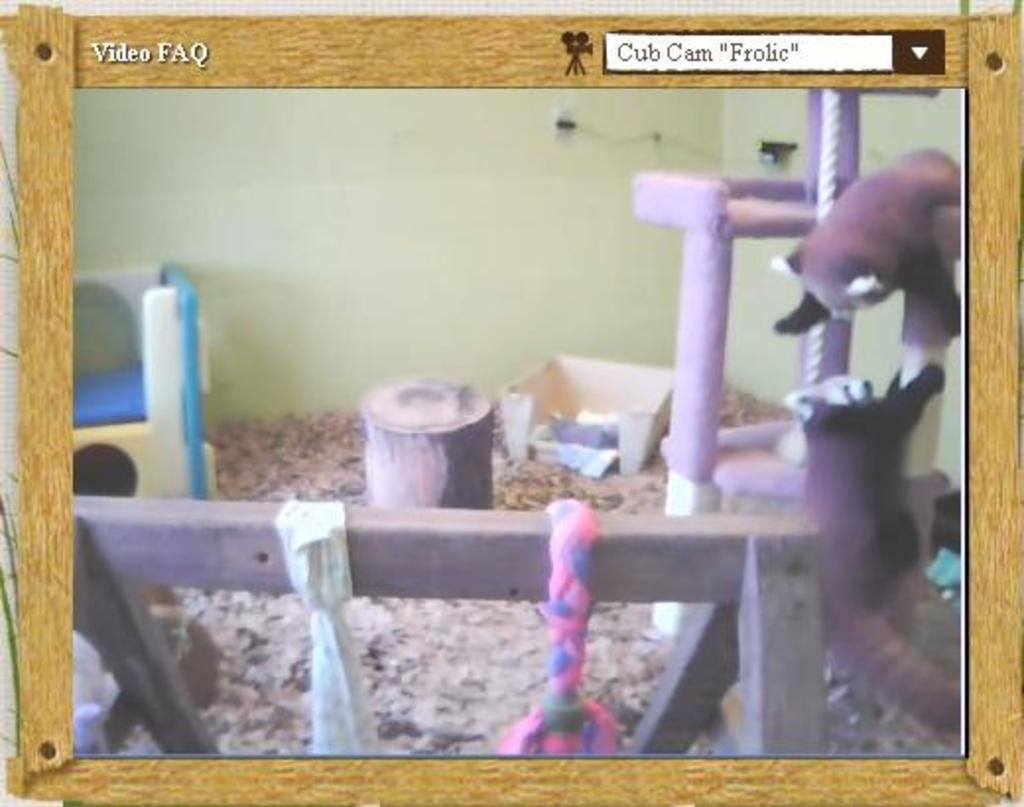What is the main subject in the center of the image? There is a poster in the center of the image. What color is the sock that is regretting its decision to invest in gold in the image? There is no sock, regret, or gold present in the image; it only features a poster. 